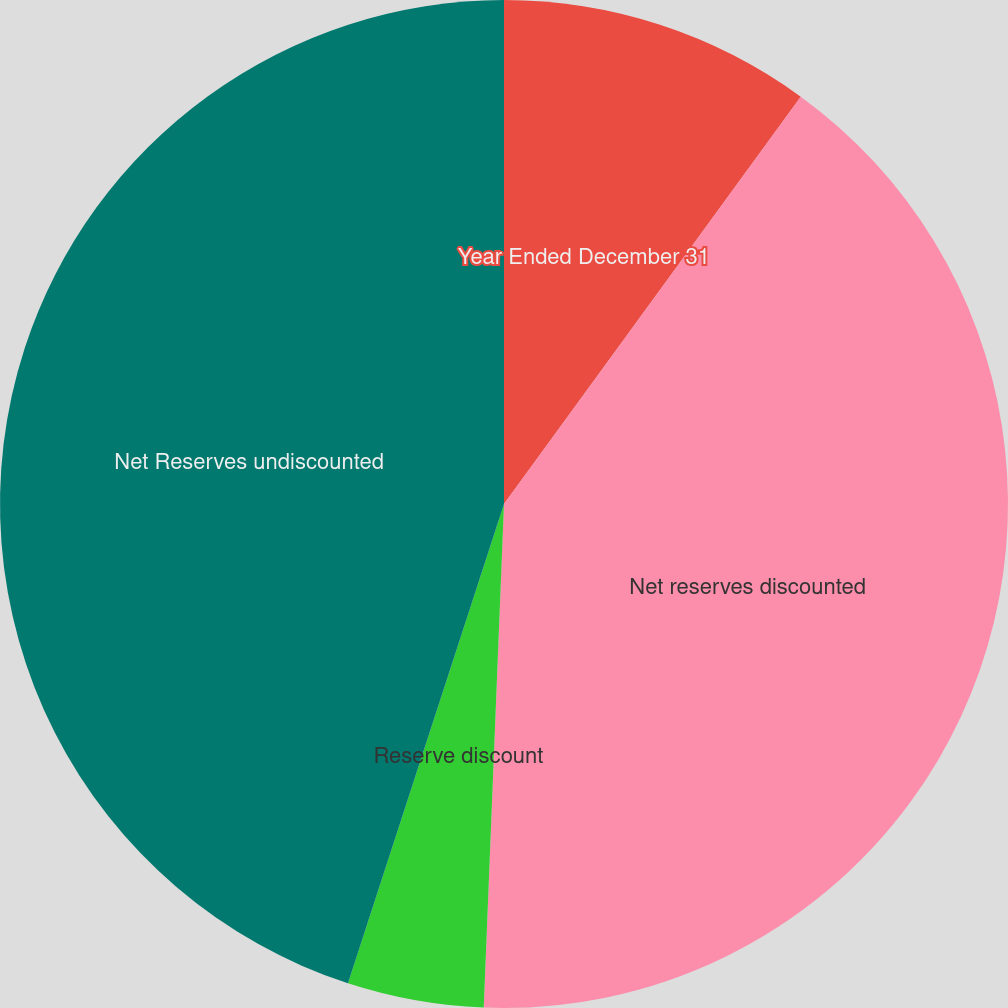Convert chart to OTSL. <chart><loc_0><loc_0><loc_500><loc_500><pie_chart><fcel>Year Ended December 31<fcel>Net reserves discounted<fcel>Reserve discount<fcel>Net Reserves undiscounted<nl><fcel>10.02%<fcel>40.62%<fcel>4.37%<fcel>44.99%<nl></chart> 